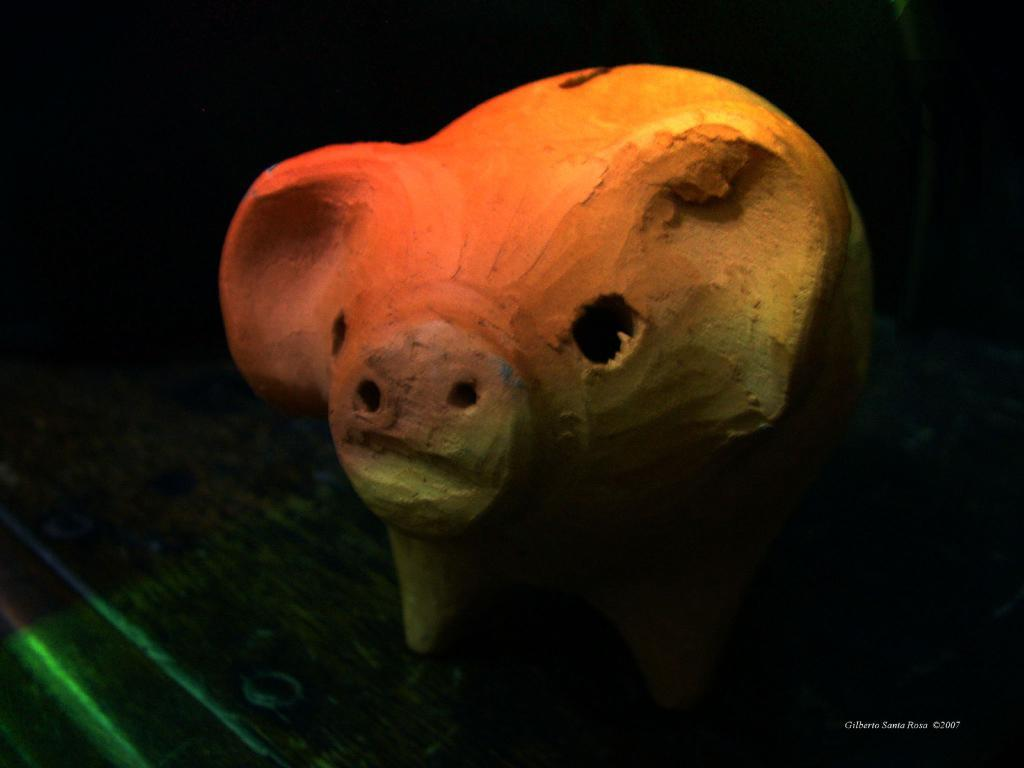What object is the main focus of the image? There is a piggy bank in the image. Where is the piggy bank located? The piggy bank is placed on a table. What type of bed can be seen in the image? There is no bed present in the image; it features a piggy bank placed on a table. How many curves are visible on the rake in the image? There is no rake present in the image. 